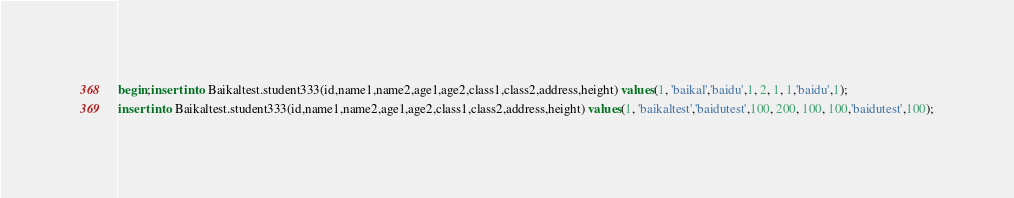<code> <loc_0><loc_0><loc_500><loc_500><_SQL_>begin;insert into Baikaltest.student333(id,name1,name2,age1,age2,class1,class2,address,height) values(1, 'baikal','baidu',1, 2, 1, 1,'baidu',1);
insert into Baikaltest.student333(id,name1,name2,age1,age2,class1,class2,address,height) values(1, 'baikaltest','baidutest',100, 200, 100, 100,'baidutest',100);
</code> 